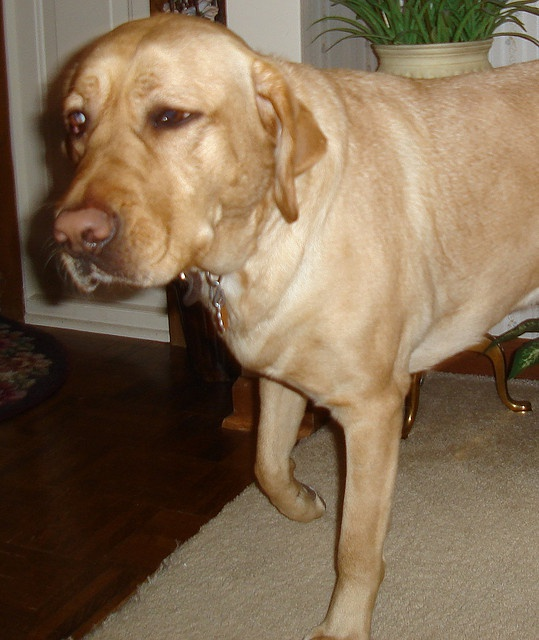Describe the objects in this image and their specific colors. I can see dog in maroon, tan, and gray tones and potted plant in maroon, darkgreen, black, and tan tones in this image. 